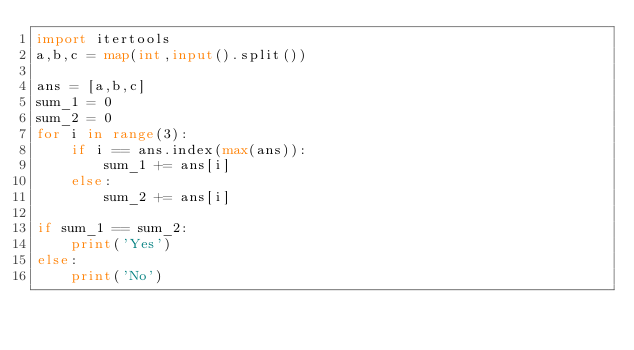Convert code to text. <code><loc_0><loc_0><loc_500><loc_500><_Python_>import itertools
a,b,c = map(int,input().split())

ans = [a,b,c]
sum_1 = 0
sum_2 = 0
for i in range(3):
    if i == ans.index(max(ans)):
        sum_1 += ans[i]
    else:
        sum_2 += ans[i]

if sum_1 == sum_2:
    print('Yes')
else:
    print('No')</code> 